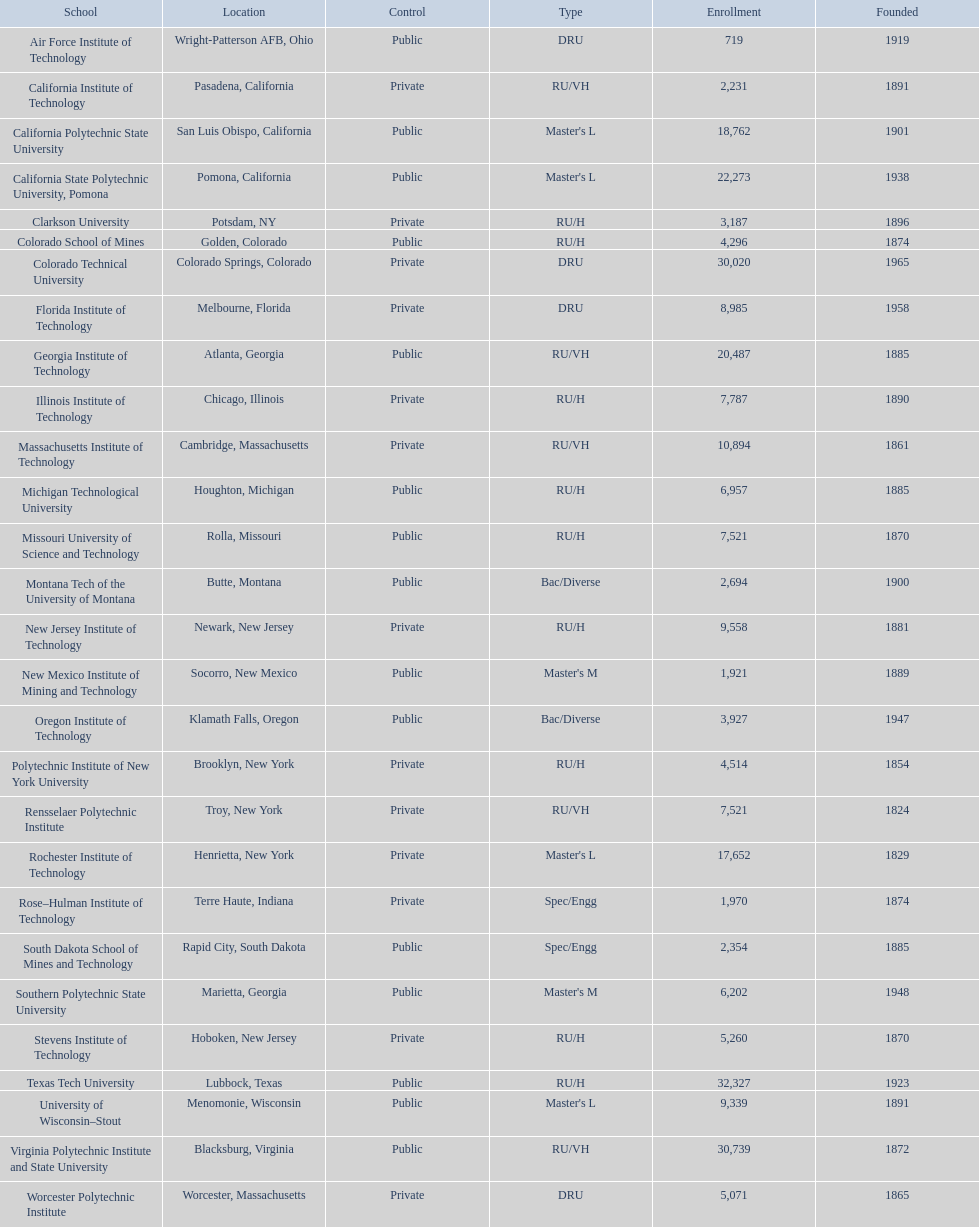How many of the universities were located in california? 3. 